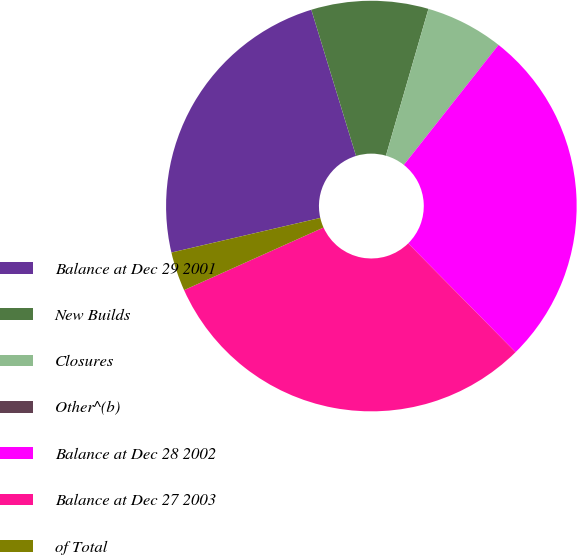<chart> <loc_0><loc_0><loc_500><loc_500><pie_chart><fcel>Balance at Dec 29 2001<fcel>New Builds<fcel>Closures<fcel>Other^(b)<fcel>Balance at Dec 28 2002<fcel>Balance at Dec 27 2003<fcel>of Total<nl><fcel>23.91%<fcel>9.21%<fcel>6.14%<fcel>0.01%<fcel>26.97%<fcel>30.68%<fcel>3.08%<nl></chart> 